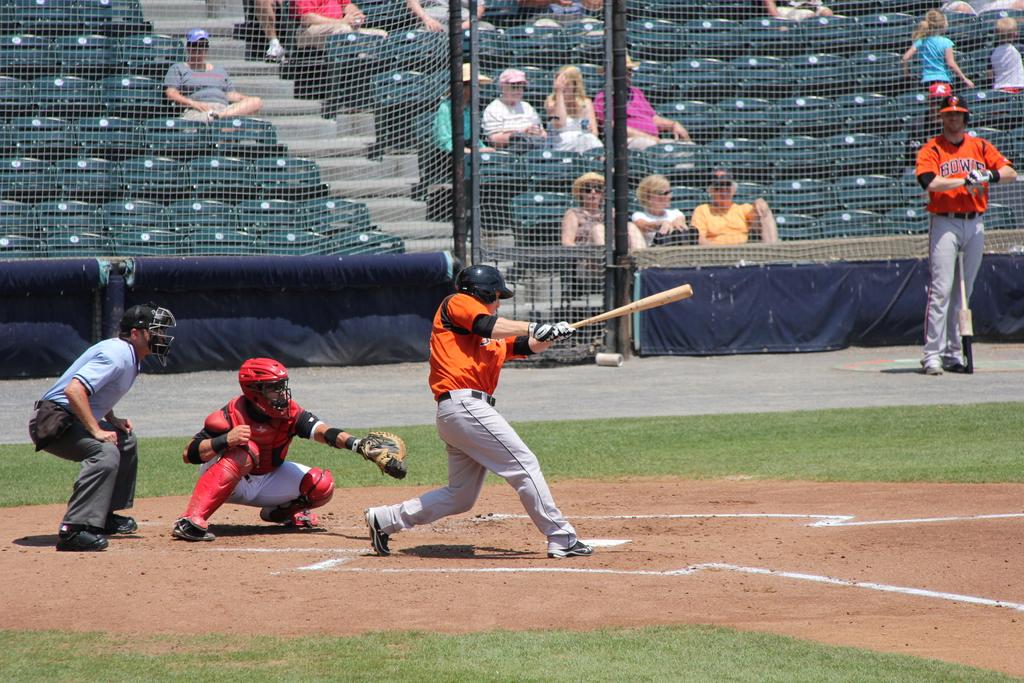Who is the opposing team?
Keep it short and to the point. Bowie. 